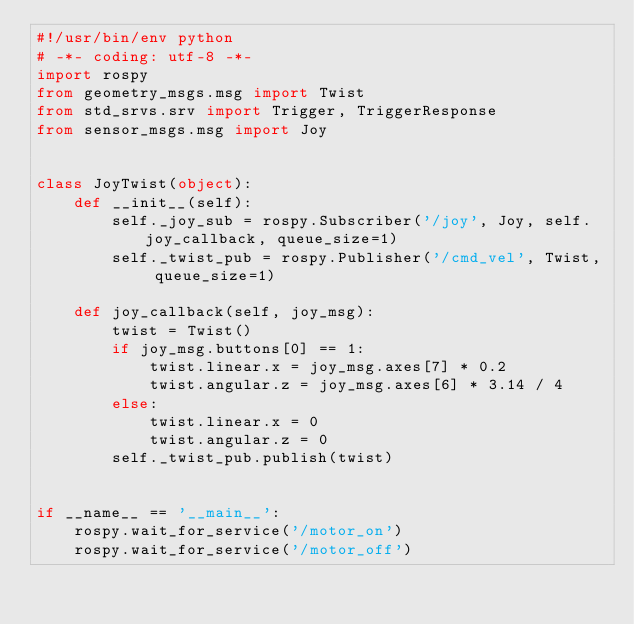Convert code to text. <code><loc_0><loc_0><loc_500><loc_500><_Python_>#!/usr/bin/env python
# -*- coding: utf-8 -*-
import rospy
from geometry_msgs.msg import Twist
from std_srvs.srv import Trigger, TriggerResponse
from sensor_msgs.msg import Joy


class JoyTwist(object):
    def __init__(self):
        self._joy_sub = rospy.Subscriber('/joy', Joy, self.joy_callback, queue_size=1)
        self._twist_pub = rospy.Publisher('/cmd_vel', Twist, queue_size=1)

    def joy_callback(self, joy_msg):
        twist = Twist()
        if joy_msg.buttons[0] == 1:
            twist.linear.x = joy_msg.axes[7] * 0.2
            twist.angular.z = joy_msg.axes[6] * 3.14 / 4
        else:
            twist.linear.x = 0
            twist.angular.z = 0
        self._twist_pub.publish(twist)


if __name__ == '__main__':
    rospy.wait_for_service('/motor_on')
    rospy.wait_for_service('/motor_off')</code> 